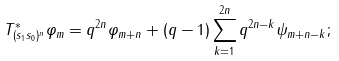Convert formula to latex. <formula><loc_0><loc_0><loc_500><loc_500>T _ { ( s _ { 1 } s _ { 0 } ) ^ { n } } ^ { * } \varphi _ { m } = q ^ { 2 n } \varphi _ { m + n } + ( q - 1 ) \sum _ { k = 1 } ^ { 2 n } q ^ { 2 n - k } \psi _ { m + n - k } ;</formula> 